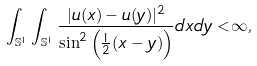Convert formula to latex. <formula><loc_0><loc_0><loc_500><loc_500>\int _ { \mathbb { S } ^ { 1 } } \int _ { \mathbb { S } ^ { 1 } } \frac { | u ( x ) - u ( y ) | ^ { 2 } } { \sin ^ { 2 } \left ( \frac { 1 } { 2 } ( x - y ) \right ) } d x d y < \infty ,</formula> 